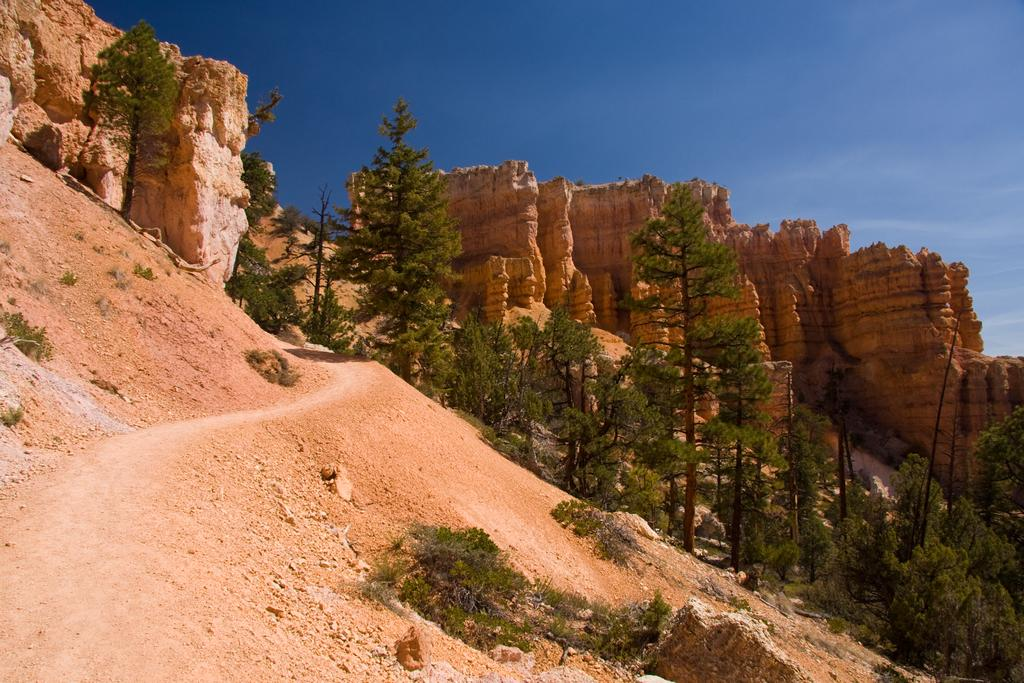What type of vegetation can be seen in the image? There are trees and plants in the image. Where are the trees and plants located? The trees and plants are on a hill. What is visible at the top of the image? The sky is visible at the top of the image. What type of leather can be seen on the field in the image? There is no leather or field present in the image; it features trees and plants on a hill with the sky visible at the top. 